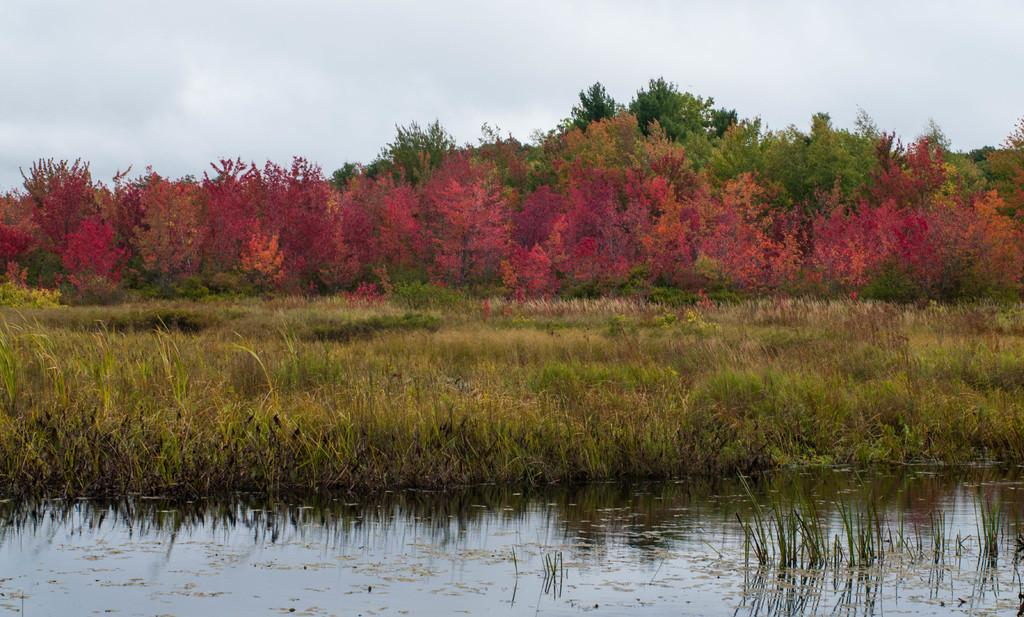What is located at the bottom of the image? There is a pond at the bottom of the image. What can be found near the pond? There are plants near the pond. What is visible in the background of the image? There are trees and flowers in the background of the image. What is visible at the top of the image? The sky is visible at the top of the image. What type of pear can be seen growing on the trees in the image? There are no pears visible in the image, as it only features trees and flowers in the background. 